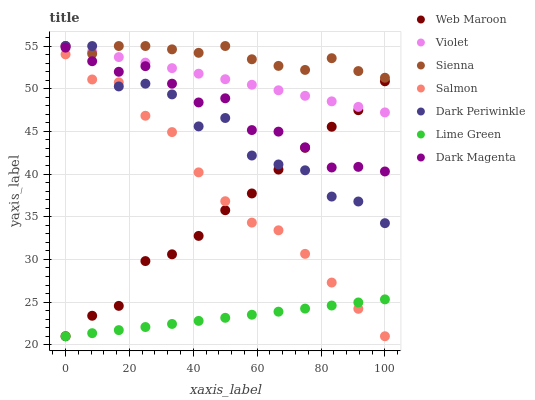Does Lime Green have the minimum area under the curve?
Answer yes or no. Yes. Does Sienna have the maximum area under the curve?
Answer yes or no. Yes. Does Web Maroon have the minimum area under the curve?
Answer yes or no. No. Does Web Maroon have the maximum area under the curve?
Answer yes or no. No. Is Violet the smoothest?
Answer yes or no. Yes. Is Dark Periwinkle the roughest?
Answer yes or no. Yes. Is Web Maroon the smoothest?
Answer yes or no. No. Is Web Maroon the roughest?
Answer yes or no. No. Does Web Maroon have the lowest value?
Answer yes or no. Yes. Does Sienna have the lowest value?
Answer yes or no. No. Does Dark Periwinkle have the highest value?
Answer yes or no. Yes. Does Web Maroon have the highest value?
Answer yes or no. No. Is Salmon less than Sienna?
Answer yes or no. Yes. Is Dark Magenta greater than Salmon?
Answer yes or no. Yes. Does Dark Periwinkle intersect Dark Magenta?
Answer yes or no. Yes. Is Dark Periwinkle less than Dark Magenta?
Answer yes or no. No. Is Dark Periwinkle greater than Dark Magenta?
Answer yes or no. No. Does Salmon intersect Sienna?
Answer yes or no. No. 